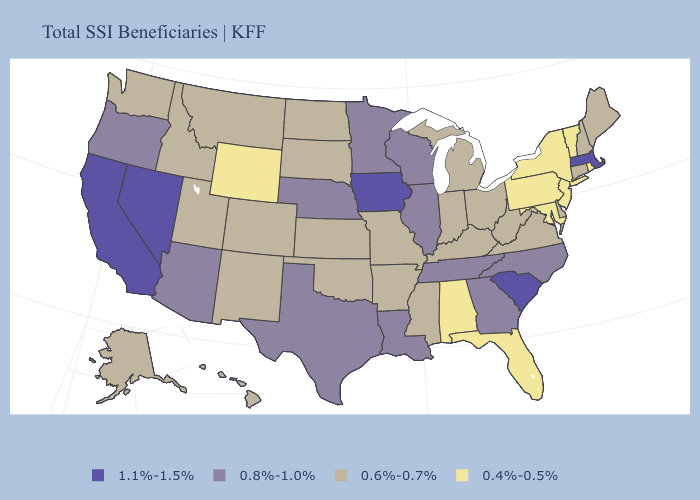Name the states that have a value in the range 0.6%-0.7%?
Give a very brief answer. Alaska, Arkansas, Colorado, Connecticut, Delaware, Hawaii, Idaho, Indiana, Kansas, Kentucky, Maine, Michigan, Mississippi, Missouri, Montana, New Hampshire, New Mexico, North Dakota, Ohio, Oklahoma, South Dakota, Utah, Virginia, Washington, West Virginia. Does Ohio have the highest value in the USA?
Write a very short answer. No. Among the states that border Washington , which have the highest value?
Answer briefly. Oregon. Does California have the highest value in the USA?
Write a very short answer. Yes. Does Nevada have the same value as Connecticut?
Be succinct. No. Which states hav the highest value in the Northeast?
Be succinct. Massachusetts. What is the highest value in the USA?
Answer briefly. 1.1%-1.5%. What is the highest value in the USA?
Be succinct. 1.1%-1.5%. Which states have the highest value in the USA?
Answer briefly. California, Iowa, Massachusetts, Nevada, South Carolina. Does South Dakota have the lowest value in the MidWest?
Concise answer only. Yes. Name the states that have a value in the range 1.1%-1.5%?
Be succinct. California, Iowa, Massachusetts, Nevada, South Carolina. Does Wisconsin have the lowest value in the MidWest?
Be succinct. No. Among the states that border Connecticut , does New York have the highest value?
Give a very brief answer. No. Which states hav the highest value in the MidWest?
Concise answer only. Iowa. Is the legend a continuous bar?
Answer briefly. No. 